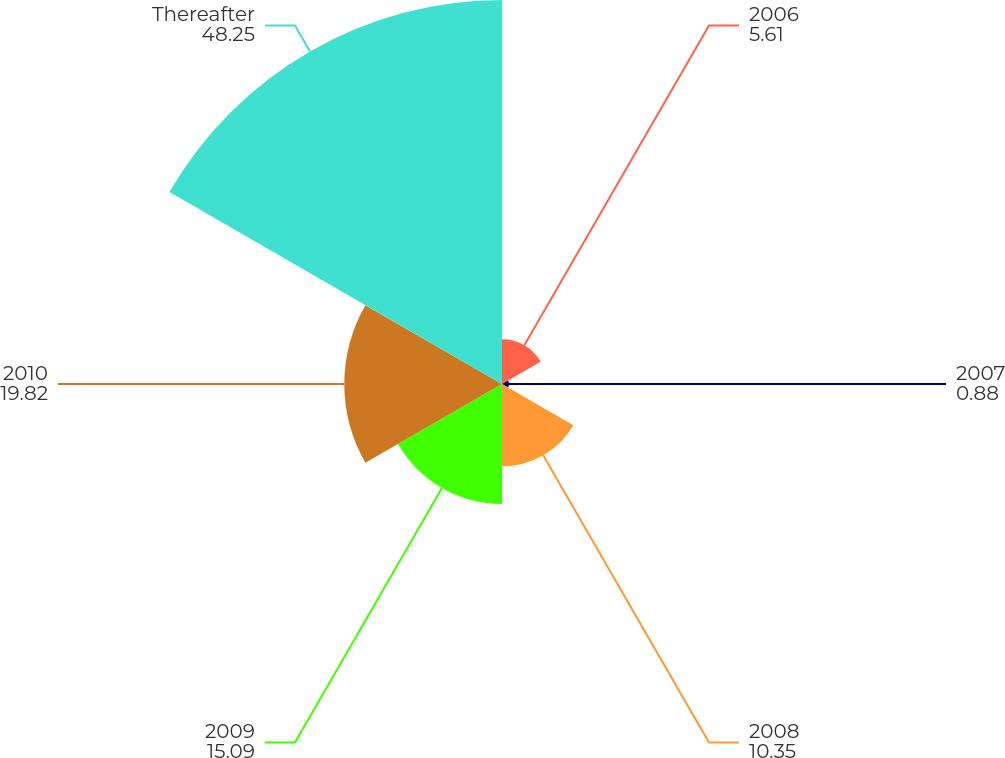Convert chart to OTSL. <chart><loc_0><loc_0><loc_500><loc_500><pie_chart><fcel>2006<fcel>2007<fcel>2008<fcel>2009<fcel>2010<fcel>Thereafter<nl><fcel>5.61%<fcel>0.88%<fcel>10.35%<fcel>15.09%<fcel>19.82%<fcel>48.25%<nl></chart> 